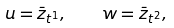Convert formula to latex. <formula><loc_0><loc_0><loc_500><loc_500>u = \bar { z } _ { t ^ { 1 } } , \text { \ \ } w = \bar { z } _ { t ^ { 2 } } ,</formula> 